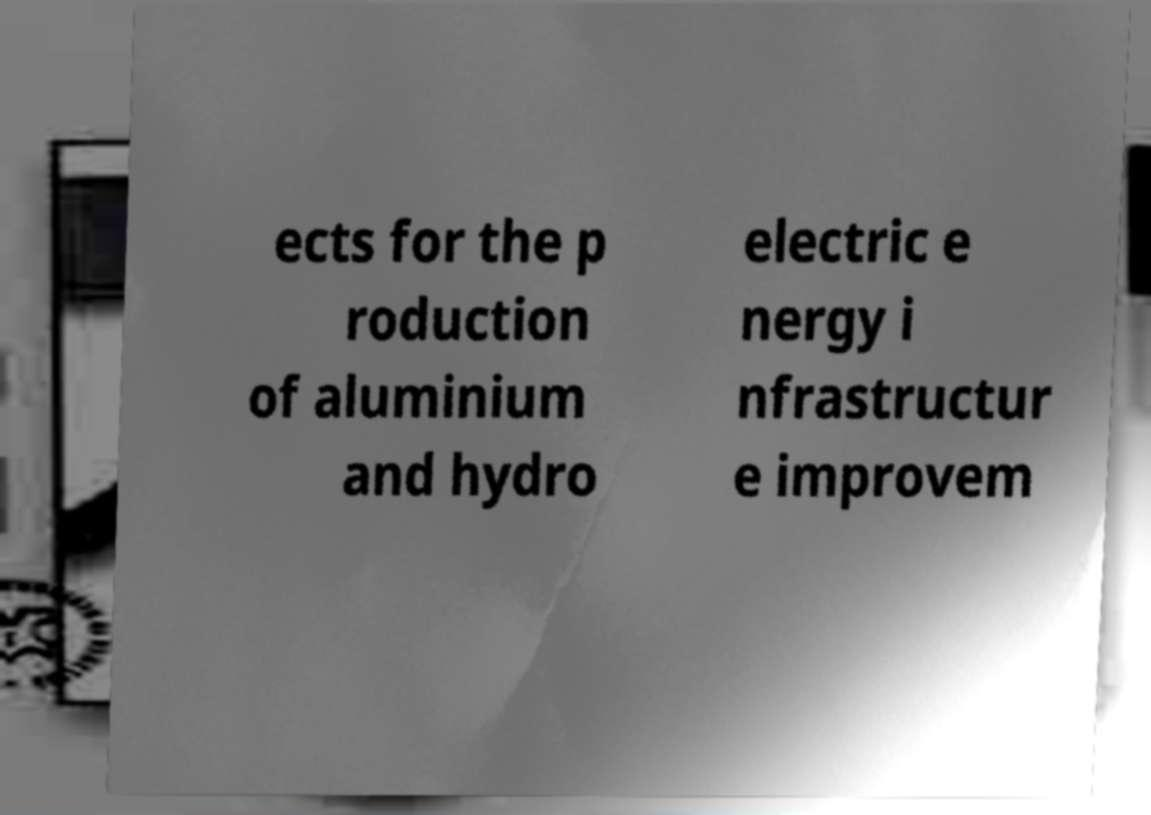Please read and relay the text visible in this image. What does it say? ects for the p roduction of aluminium and hydro electric e nergy i nfrastructur e improvem 